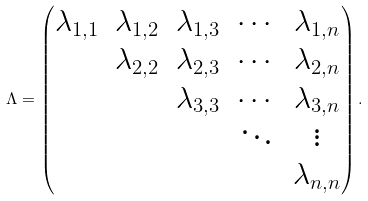Convert formula to latex. <formula><loc_0><loc_0><loc_500><loc_500>\Lambda = \left ( \begin{matrix} \lambda _ { 1 , 1 } & \lambda _ { 1 , 2 } & \lambda _ { 1 , 3 } & \cdots & \lambda _ { 1 , n } \\ & \lambda _ { 2 , 2 } & \lambda _ { 2 , 3 } & \cdots & \lambda _ { 2 , n } \\ & & \lambda _ { 3 , 3 } & \cdots & \lambda _ { 3 , n } \\ & & & \ddots & \vdots \\ & & & & \lambda _ { n , n } \end{matrix} \right ) .</formula> 